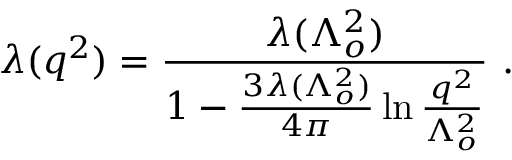<formula> <loc_0><loc_0><loc_500><loc_500>\lambda ( q ^ { 2 } ) = \frac { \lambda ( \Lambda _ { o } ^ { 2 } ) } { 1 - \frac { 3 \lambda ( \Lambda _ { o } ^ { 2 } ) } { 4 \pi } \ln \frac { q ^ { 2 } } { \Lambda _ { o } ^ { 2 } } } .</formula> 